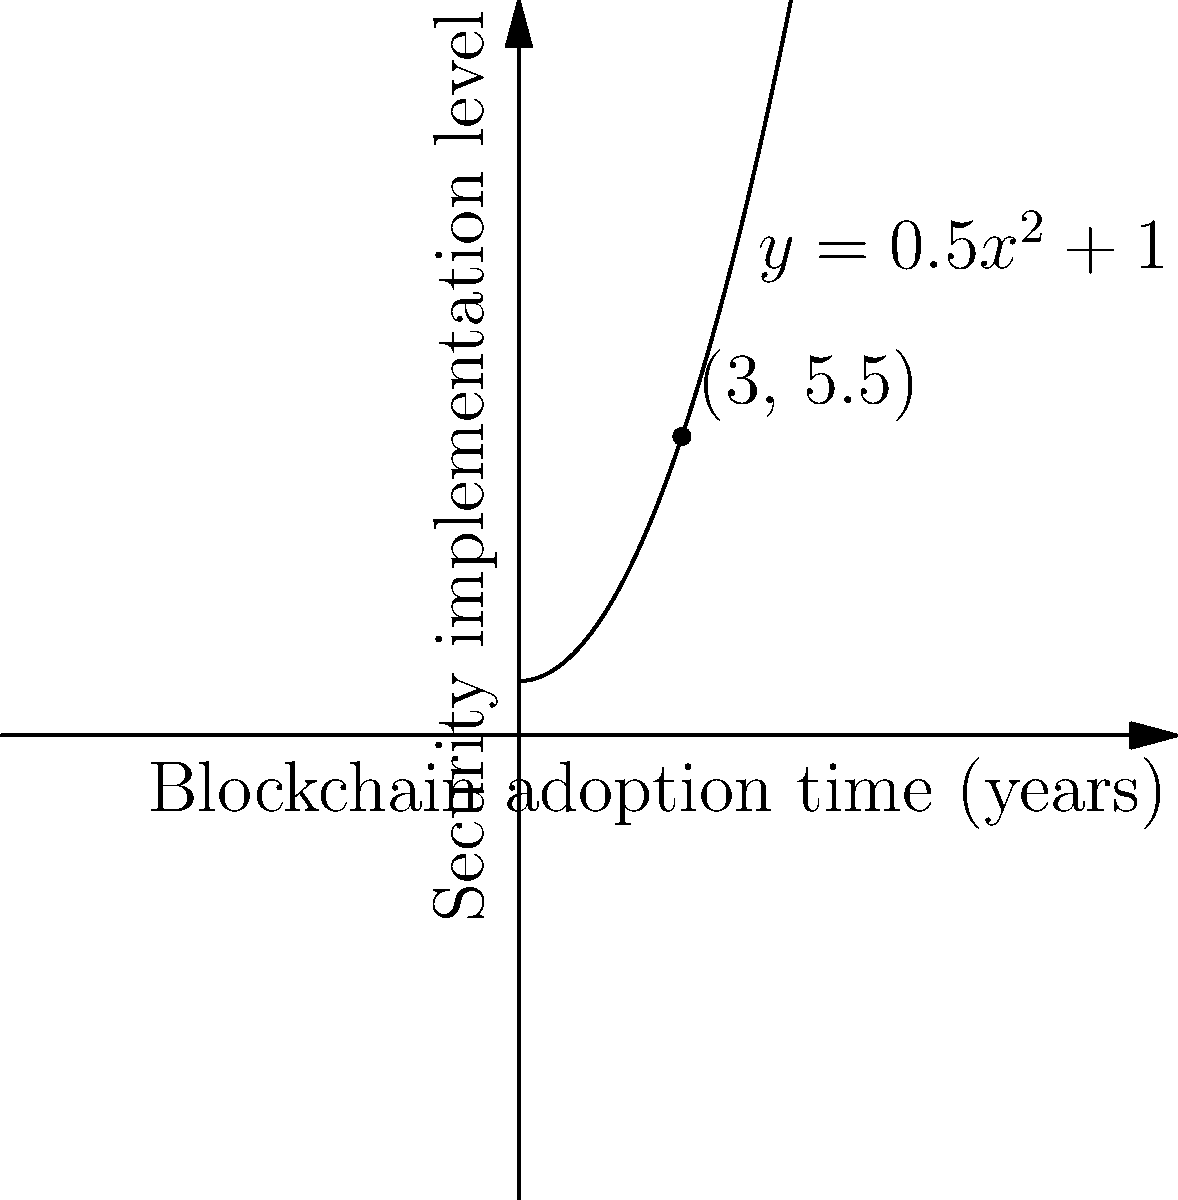A blockchain security startup's growth is modeled by the parabola $y = 0.5x^2 + 1$, where $x$ represents the time in years since the company's inception, and $y$ represents the level of security implementation on a scale of 1 to 10. After how many years will the company reach a security implementation level of 8.5? To solve this problem, we need to follow these steps:

1) We are given the equation of the parabola: $y = 0.5x^2 + 1$

2) We want to find $x$ when $y = 8.5$. So, let's substitute this:

   $8.5 = 0.5x^2 + 1$

3) Subtract 1 from both sides:

   $7.5 = 0.5x^2$

4) Multiply both sides by 2:

   $15 = x^2$

5) Take the square root of both sides:

   $\sqrt{15} = x$

6) Simplify:

   $x = \sqrt{15} \approx 3.87$ years

Therefore, it will take approximately 3.87 years for the company to reach a security implementation level of 8.5.
Answer: $\sqrt{15}$ years 